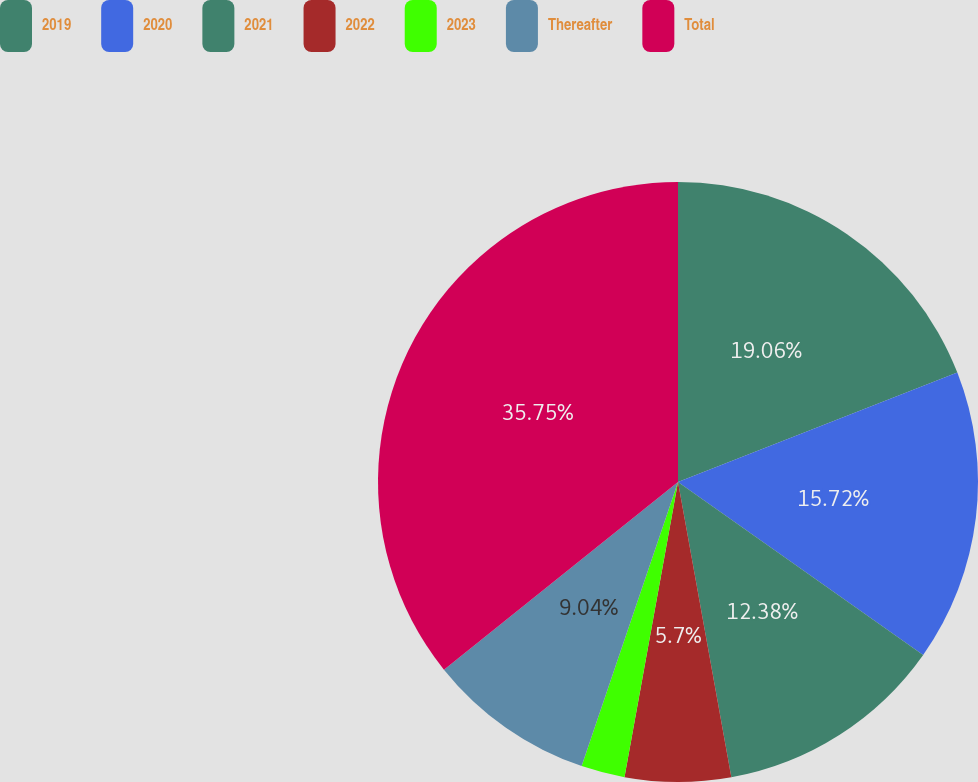<chart> <loc_0><loc_0><loc_500><loc_500><pie_chart><fcel>2019<fcel>2020<fcel>2021<fcel>2022<fcel>2023<fcel>Thereafter<fcel>Total<nl><fcel>19.06%<fcel>15.72%<fcel>12.38%<fcel>5.7%<fcel>2.35%<fcel>9.04%<fcel>35.76%<nl></chart> 